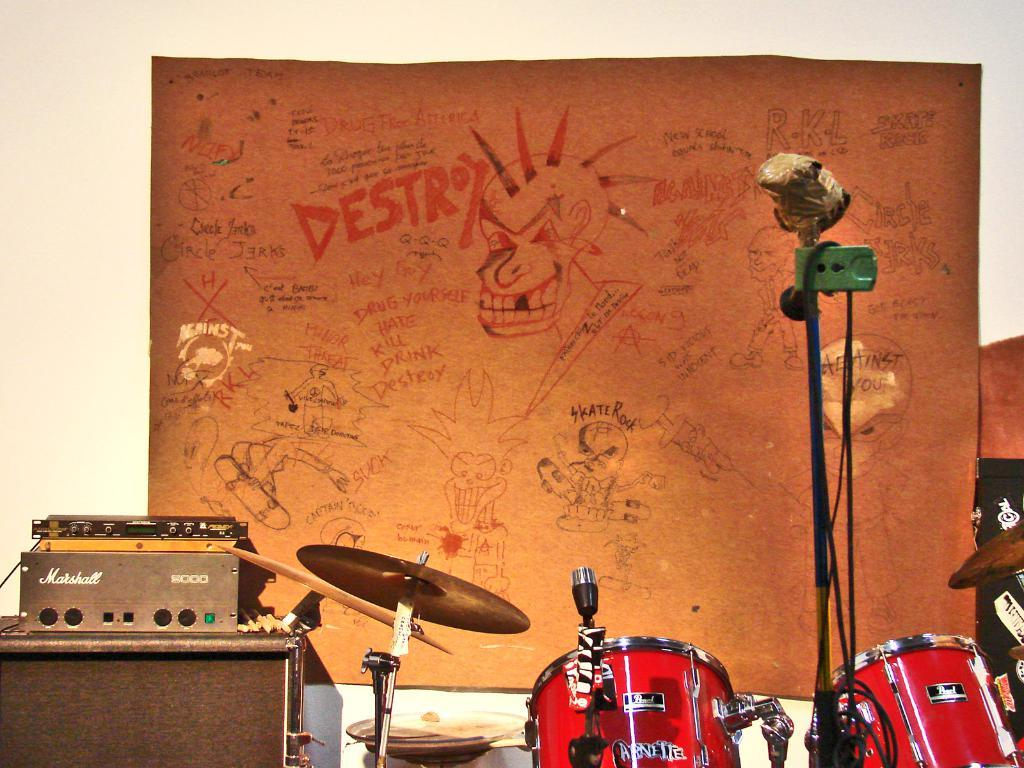Provide a one-sentence caption for the provided image. the backdrop for a band has lots of graffiti including Skate Rock and Destroy. 